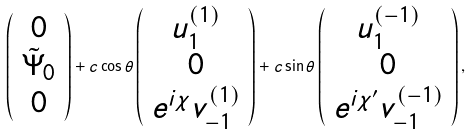<formula> <loc_0><loc_0><loc_500><loc_500>\left ( \begin{array} { c } 0 \\ \tilde { \Psi } _ { 0 } \\ 0 \end{array} \right ) + c \cos \theta \left ( \begin{array} { c } u _ { 1 } ^ { ( 1 ) } \\ 0 \\ e ^ { i \chi } v _ { - 1 } ^ { ( 1 ) } \end{array} \right ) + c \sin \theta \left ( \begin{array} { c } u _ { 1 } ^ { ( - 1 ) } \\ 0 \\ e ^ { i \chi ^ { \prime } } v _ { - 1 } ^ { ( - 1 ) } \end{array} \right ) ,</formula> 